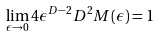Convert formula to latex. <formula><loc_0><loc_0><loc_500><loc_500>\lim _ { \epsilon \to 0 } 4 \epsilon ^ { D - 2 } D ^ { 2 } M ( \epsilon ) = 1</formula> 